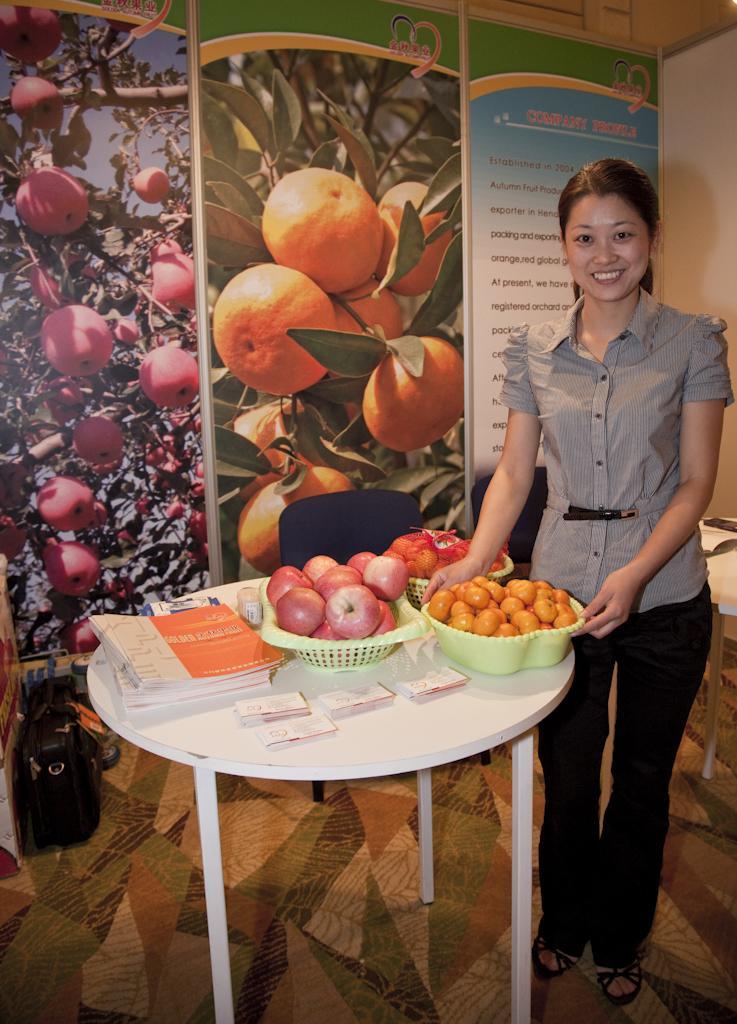Could you give a brief overview of what you see in this image? In this image I can see the person wearing the ash and black color dress. In-front of the person I can see the table. On the table I can see the books, cards and the bowls with vegetables. In the background I can see the banners and there is a bag on the floor. 